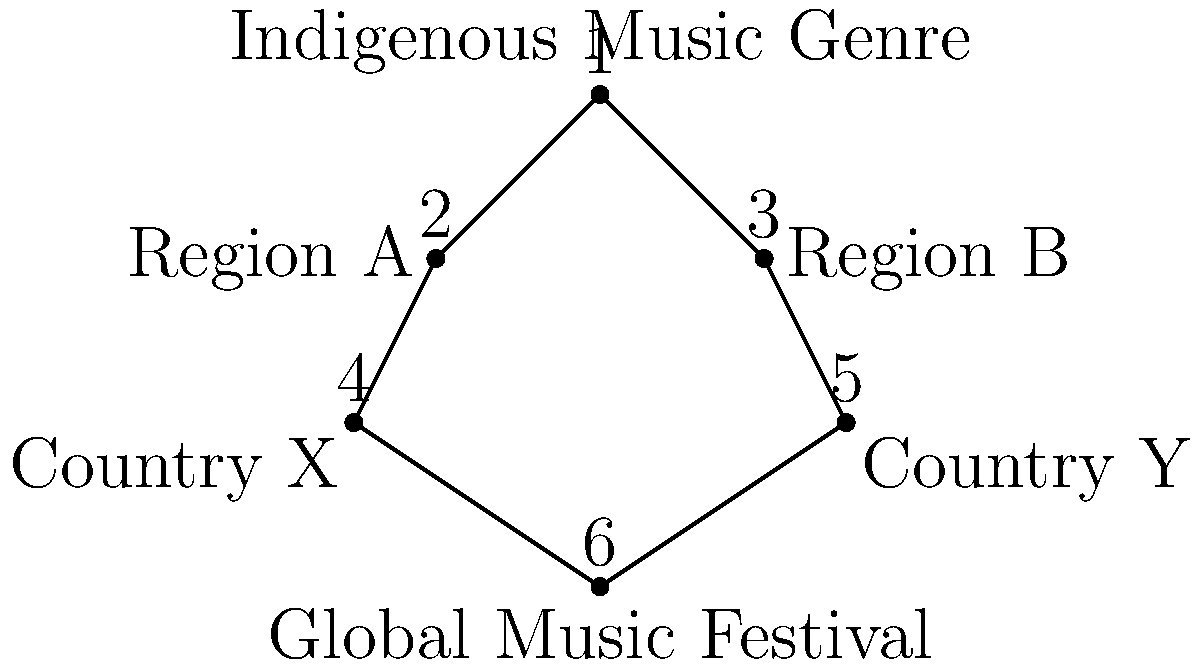In the network diagram representing the global spread of an indigenous music genre, what is the minimum number of edges that need to be traversed to connect the original indigenous music genre to the global music festival? To solve this problem, we need to follow these steps:

1. Identify the starting point (Indigenous Music Genre) and the endpoint (Global Music Festival) in the network diagram.
2. Analyze all possible paths from the starting point to the endpoint.
3. Count the number of edges in each path.
4. Determine the path with the minimum number of edges.

Let's examine the possible paths:

Path 1: Indigenous Music Genre → Region A → Country X → Global Music Festival
Number of edges: 3

Path 2: Indigenous Music Genre → Region B → Country Y → Global Music Festival
Number of edges: 3

Both paths have the same number of edges, which is 3. This is the minimum number of edges required to connect the Indigenous Music Genre to the Global Music Festival.

It's worth noting that in network analysis, the number of edges in the shortest path between two nodes is often referred to as the "geodesic distance" or "shortest path length".
Answer: 3 edges 